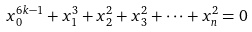<formula> <loc_0><loc_0><loc_500><loc_500>x _ { 0 } ^ { 6 k - 1 } + x _ { 1 } ^ { 3 } + x _ { 2 } ^ { 2 } + x _ { 3 } ^ { 2 } + \dots + x _ { n } ^ { 2 } = 0</formula> 